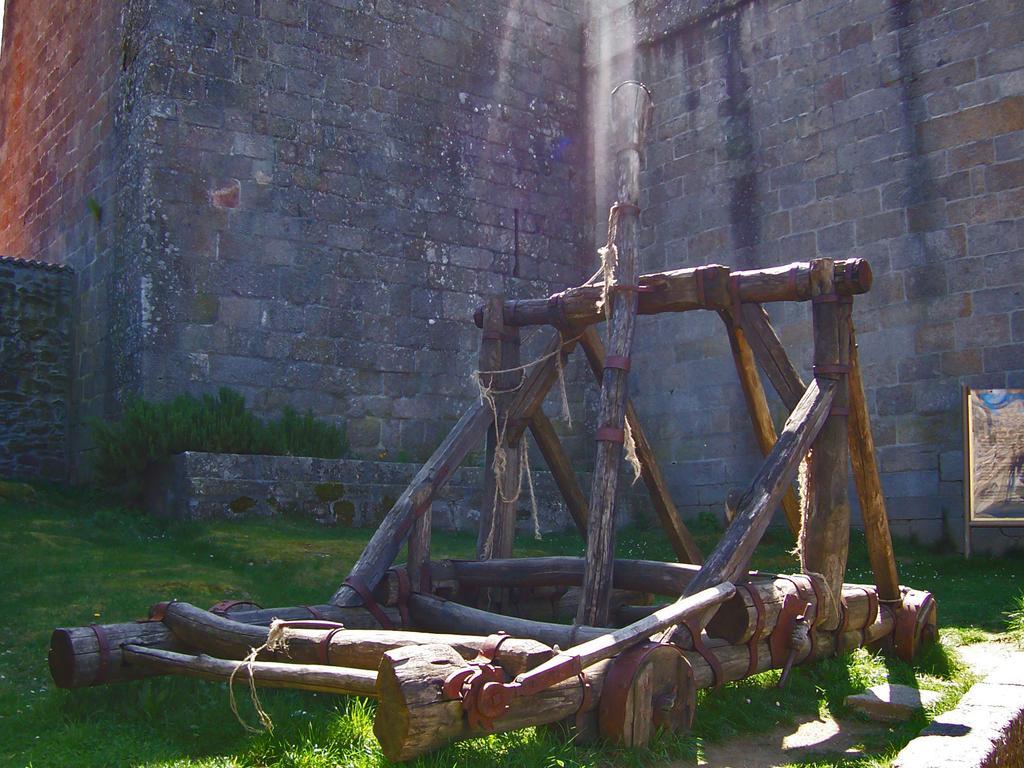Describe this image in one or two sentences. In the middle of the image we can see few wooden barks, in the background we can find few plants, grass and a board. 